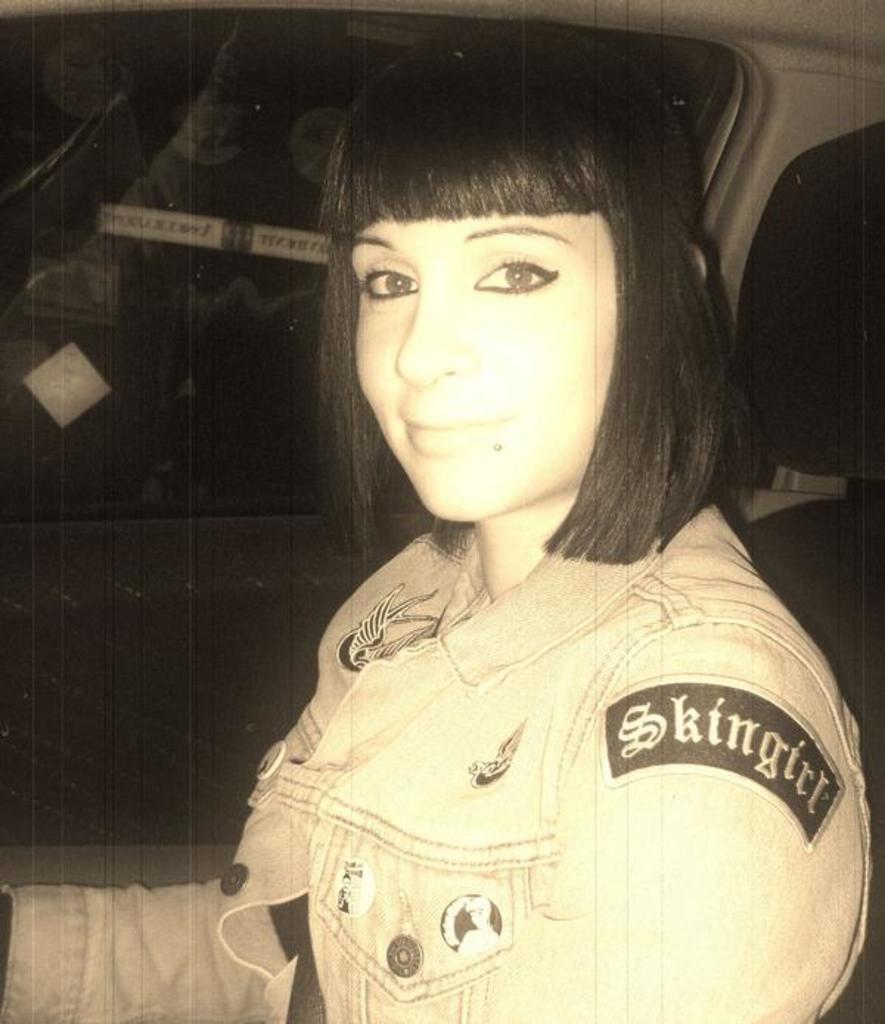Please provide a concise description of this image. In this image we can see a girl is sitting inside a vehicle. She is wearing a jacket. In the background, we can see a window. 